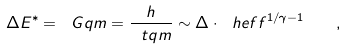Convert formula to latex. <formula><loc_0><loc_0><loc_500><loc_500>\Delta E ^ { * } = \ G q m = \frac { h } { \ t q m } \sim \Delta \cdot \ h e f f ^ { 1 / \gamma - 1 } \quad ,</formula> 